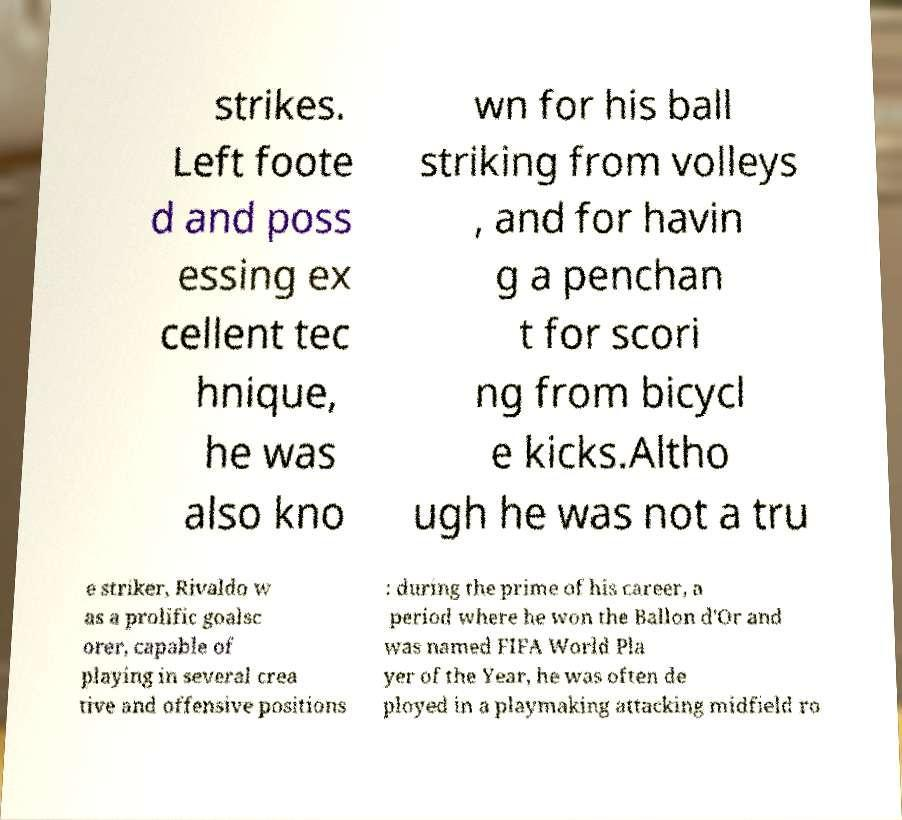I need the written content from this picture converted into text. Can you do that? strikes. Left foote d and poss essing ex cellent tec hnique, he was also kno wn for his ball striking from volleys , and for havin g a penchan t for scori ng from bicycl e kicks.Altho ugh he was not a tru e striker, Rivaldo w as a prolific goalsc orer, capable of playing in several crea tive and offensive positions : during the prime of his career, a period where he won the Ballon d'Or and was named FIFA World Pla yer of the Year, he was often de ployed in a playmaking attacking midfield ro 